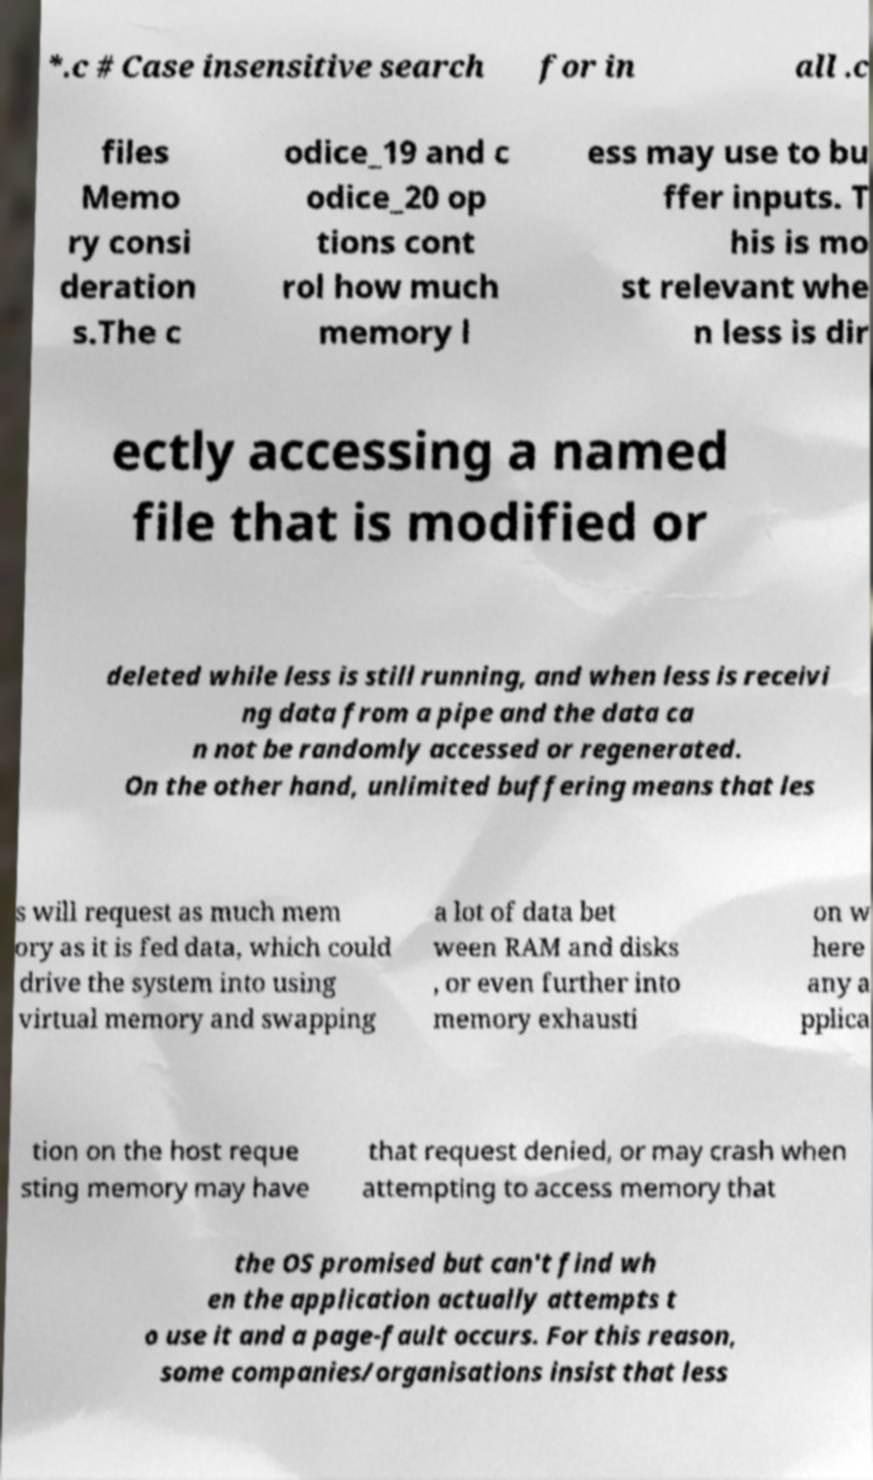I need the written content from this picture converted into text. Can you do that? *.c # Case insensitive search for in all .c files Memo ry consi deration s.The c odice_19 and c odice_20 op tions cont rol how much memory l ess may use to bu ffer inputs. T his is mo st relevant whe n less is dir ectly accessing a named file that is modified or deleted while less is still running, and when less is receivi ng data from a pipe and the data ca n not be randomly accessed or regenerated. On the other hand, unlimited buffering means that les s will request as much mem ory as it is fed data, which could drive the system into using virtual memory and swapping a lot of data bet ween RAM and disks , or even further into memory exhausti on w here any a pplica tion on the host reque sting memory may have that request denied, or may crash when attempting to access memory that the OS promised but can't find wh en the application actually attempts t o use it and a page-fault occurs. For this reason, some companies/organisations insist that less 